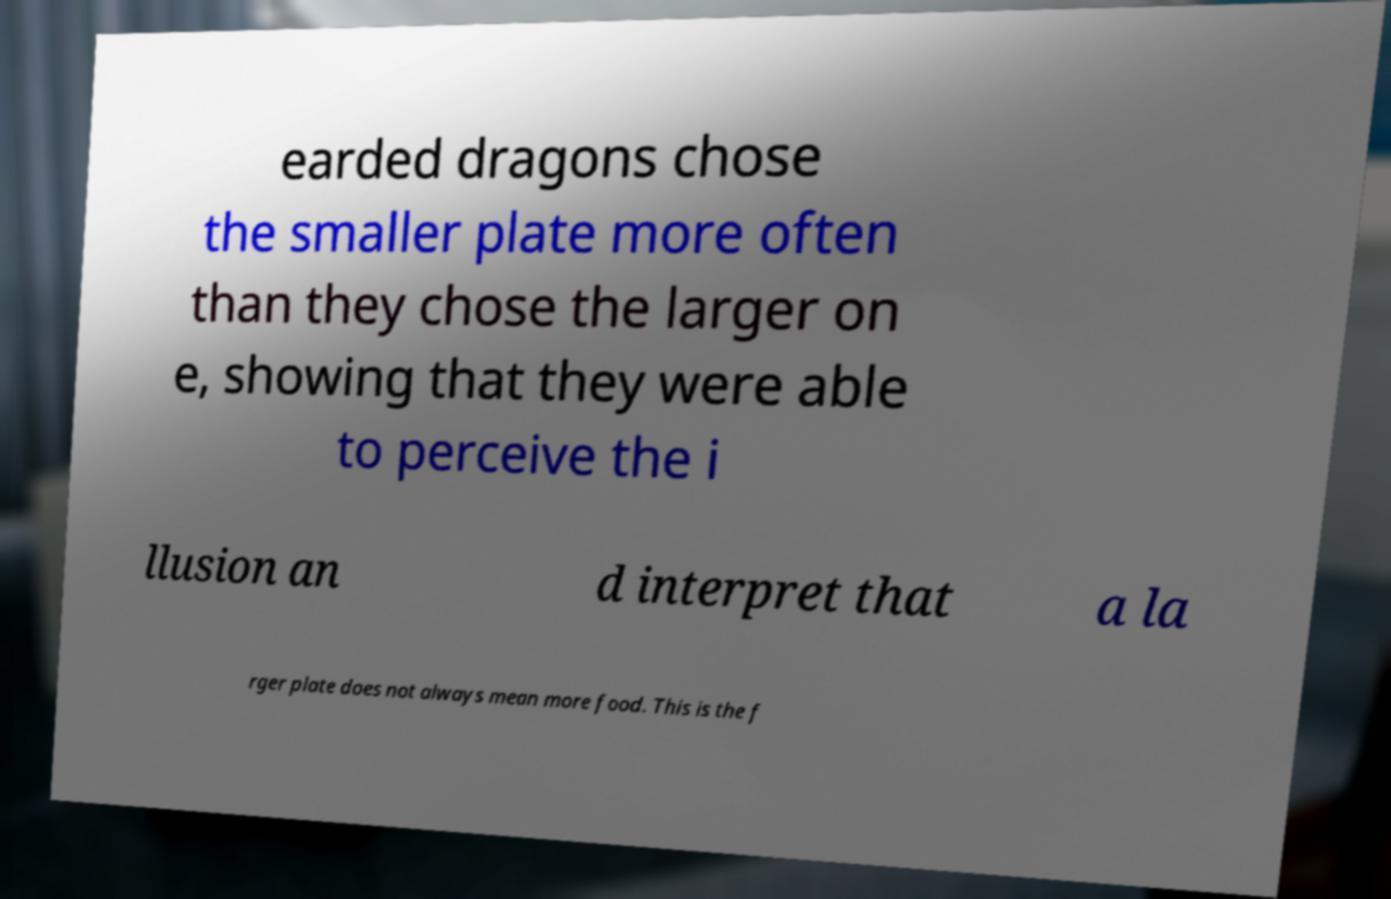Please identify and transcribe the text found in this image. earded dragons chose the smaller plate more often than they chose the larger on e, showing that they were able to perceive the i llusion an d interpret that a la rger plate does not always mean more food. This is the f 